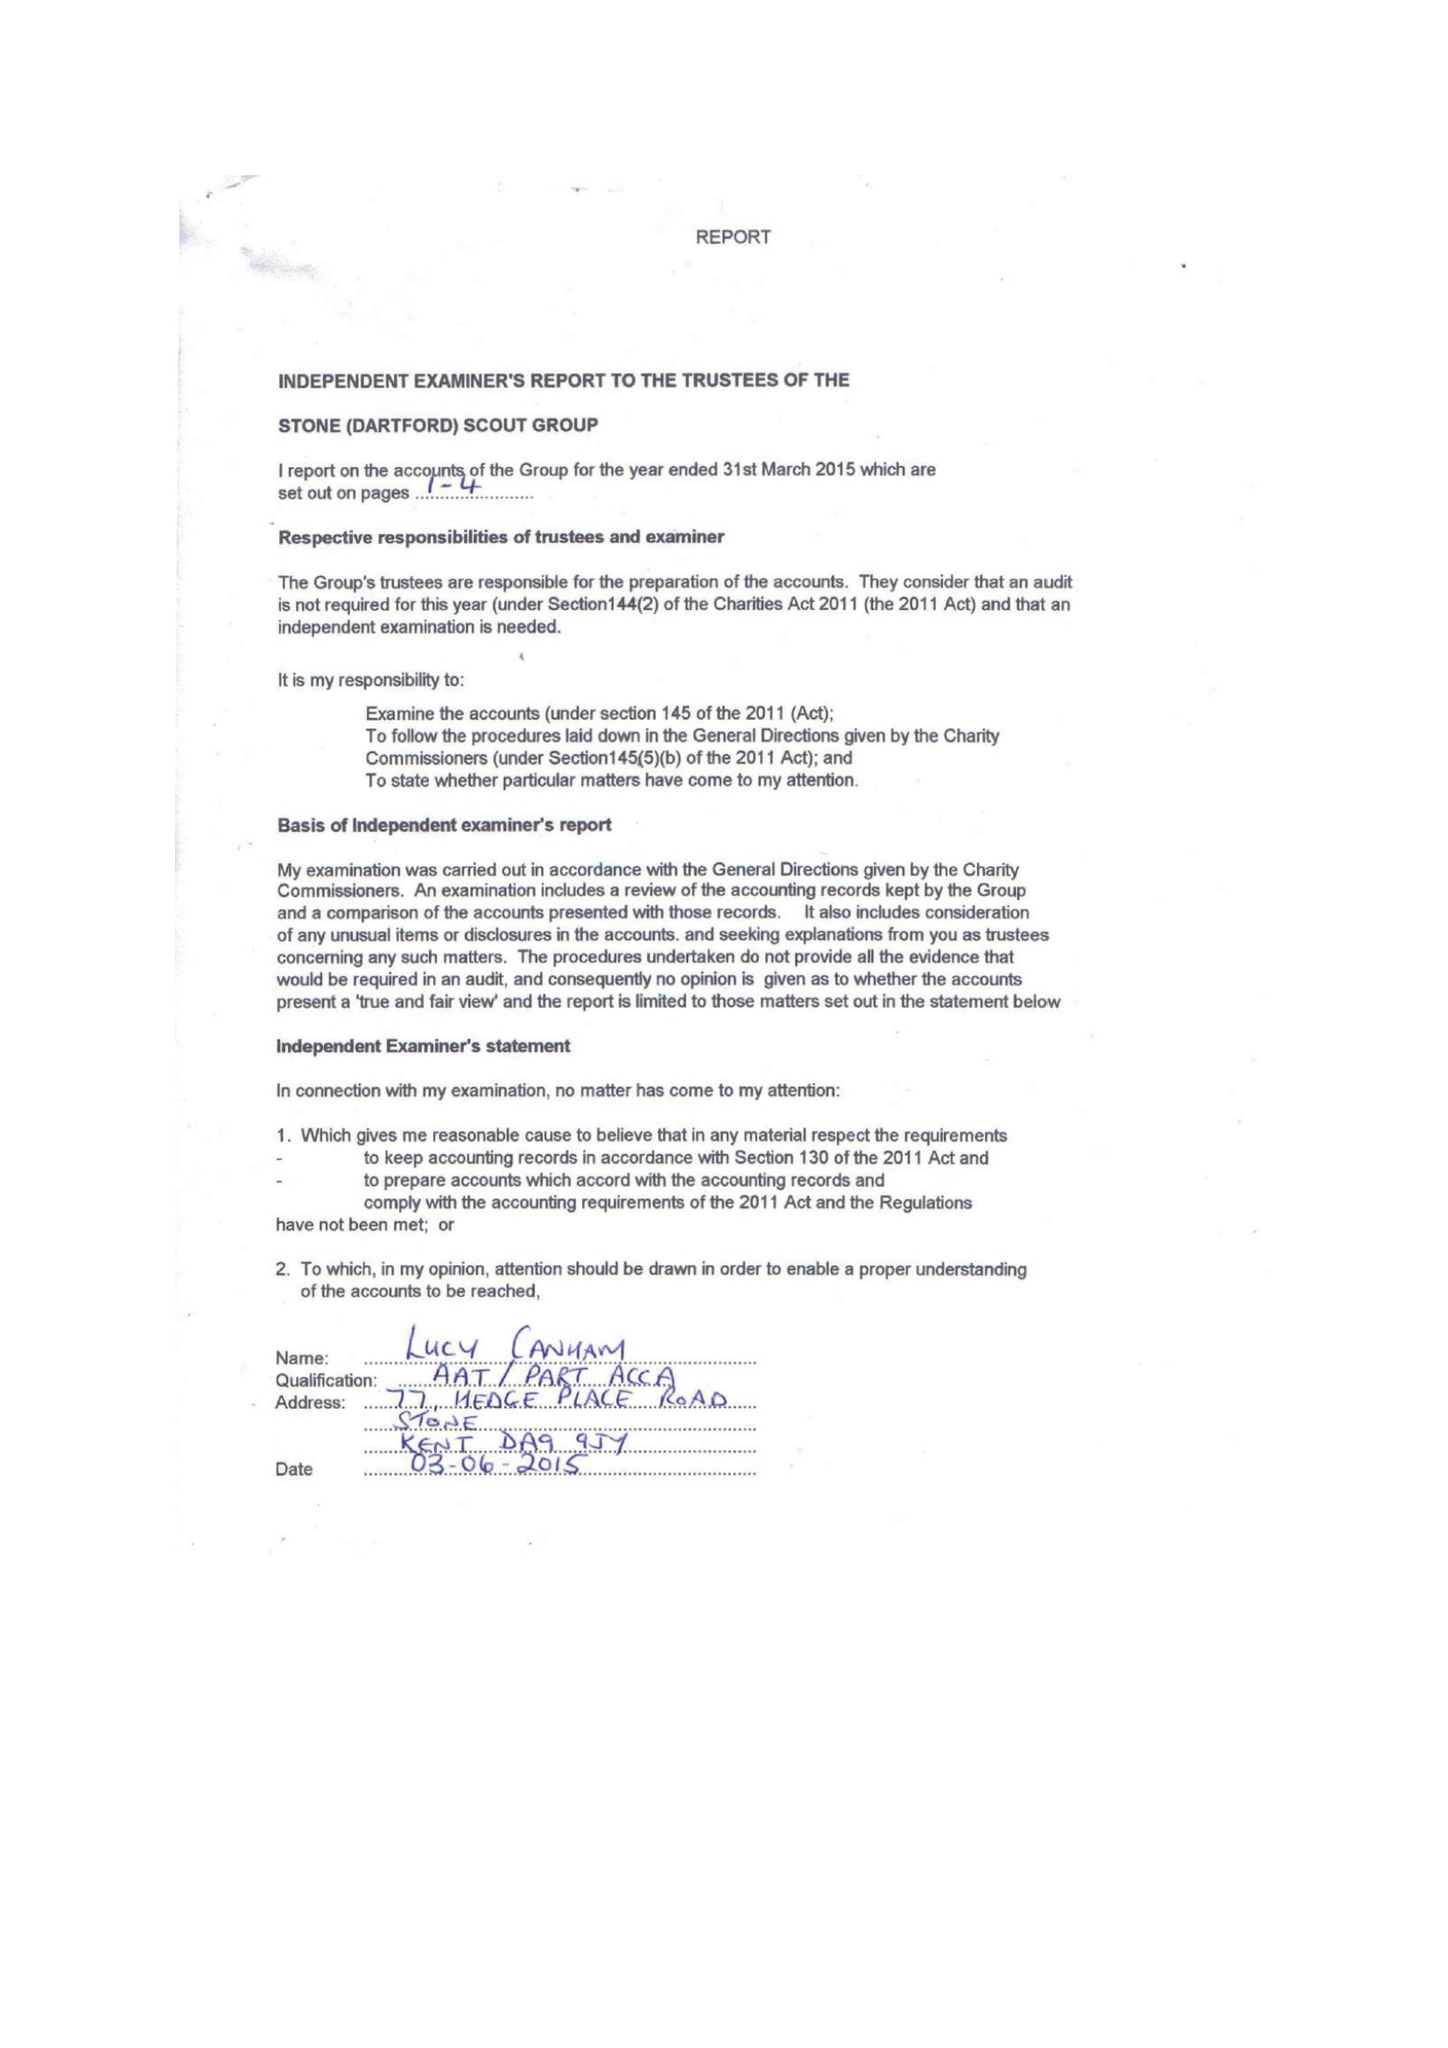What is the value for the address__postcode?
Answer the question using a single word or phrase. DA9 9QZ 